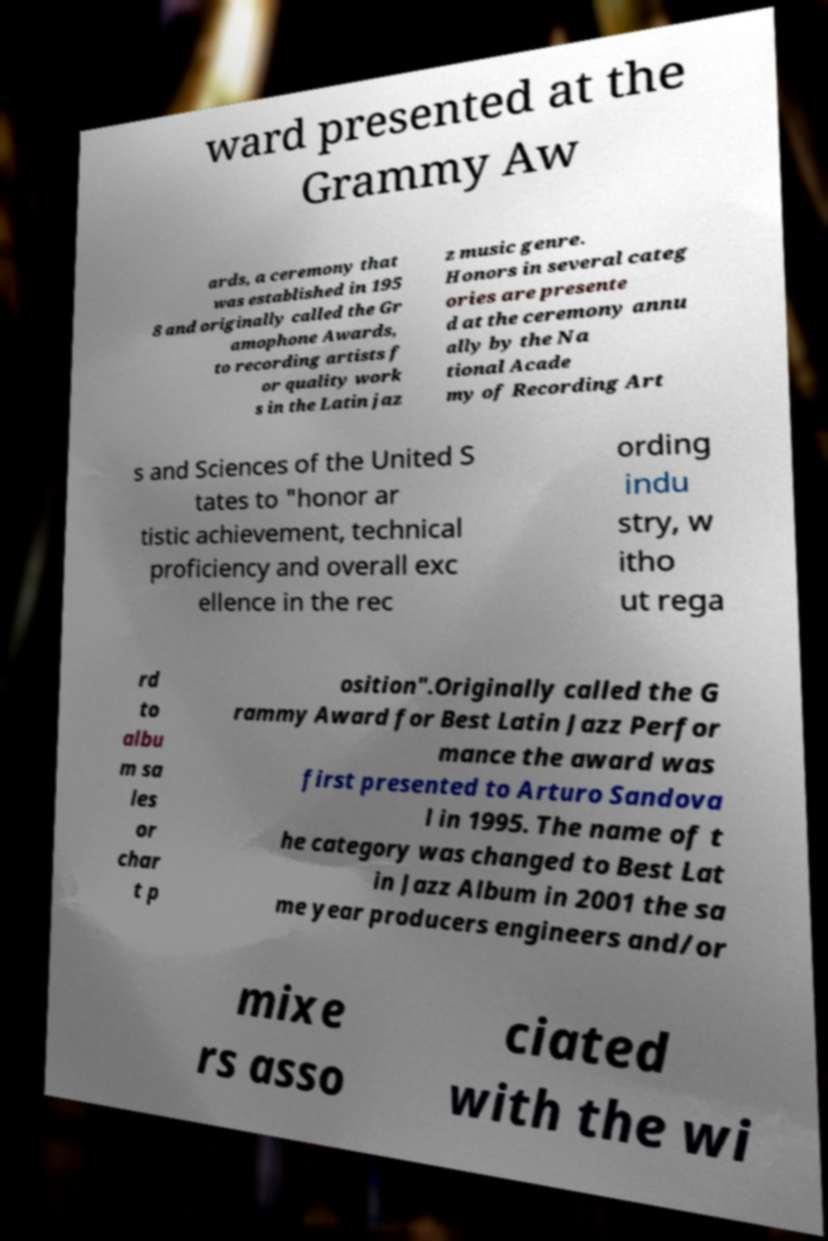I need the written content from this picture converted into text. Can you do that? ward presented at the Grammy Aw ards, a ceremony that was established in 195 8 and originally called the Gr amophone Awards, to recording artists f or quality work s in the Latin jaz z music genre. Honors in several categ ories are presente d at the ceremony annu ally by the Na tional Acade my of Recording Art s and Sciences of the United S tates to "honor ar tistic achievement, technical proficiency and overall exc ellence in the rec ording indu stry, w itho ut rega rd to albu m sa les or char t p osition".Originally called the G rammy Award for Best Latin Jazz Perfor mance the award was first presented to Arturo Sandova l in 1995. The name of t he category was changed to Best Lat in Jazz Album in 2001 the sa me year producers engineers and/or mixe rs asso ciated with the wi 